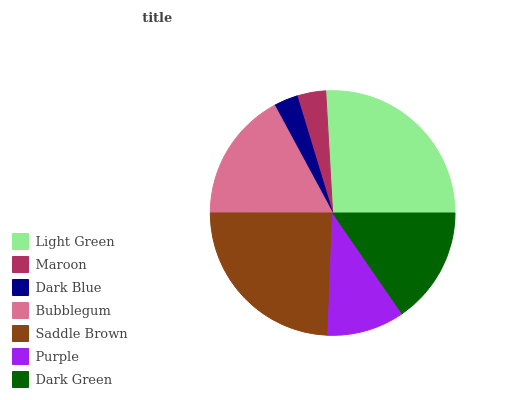Is Dark Blue the minimum?
Answer yes or no. Yes. Is Light Green the maximum?
Answer yes or no. Yes. Is Maroon the minimum?
Answer yes or no. No. Is Maroon the maximum?
Answer yes or no. No. Is Light Green greater than Maroon?
Answer yes or no. Yes. Is Maroon less than Light Green?
Answer yes or no. Yes. Is Maroon greater than Light Green?
Answer yes or no. No. Is Light Green less than Maroon?
Answer yes or no. No. Is Dark Green the high median?
Answer yes or no. Yes. Is Dark Green the low median?
Answer yes or no. Yes. Is Light Green the high median?
Answer yes or no. No. Is Light Green the low median?
Answer yes or no. No. 